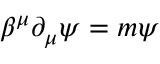<formula> <loc_0><loc_0><loc_500><loc_500>\beta ^ { \mu } \partial _ { \mu } \psi = m \psi</formula> 